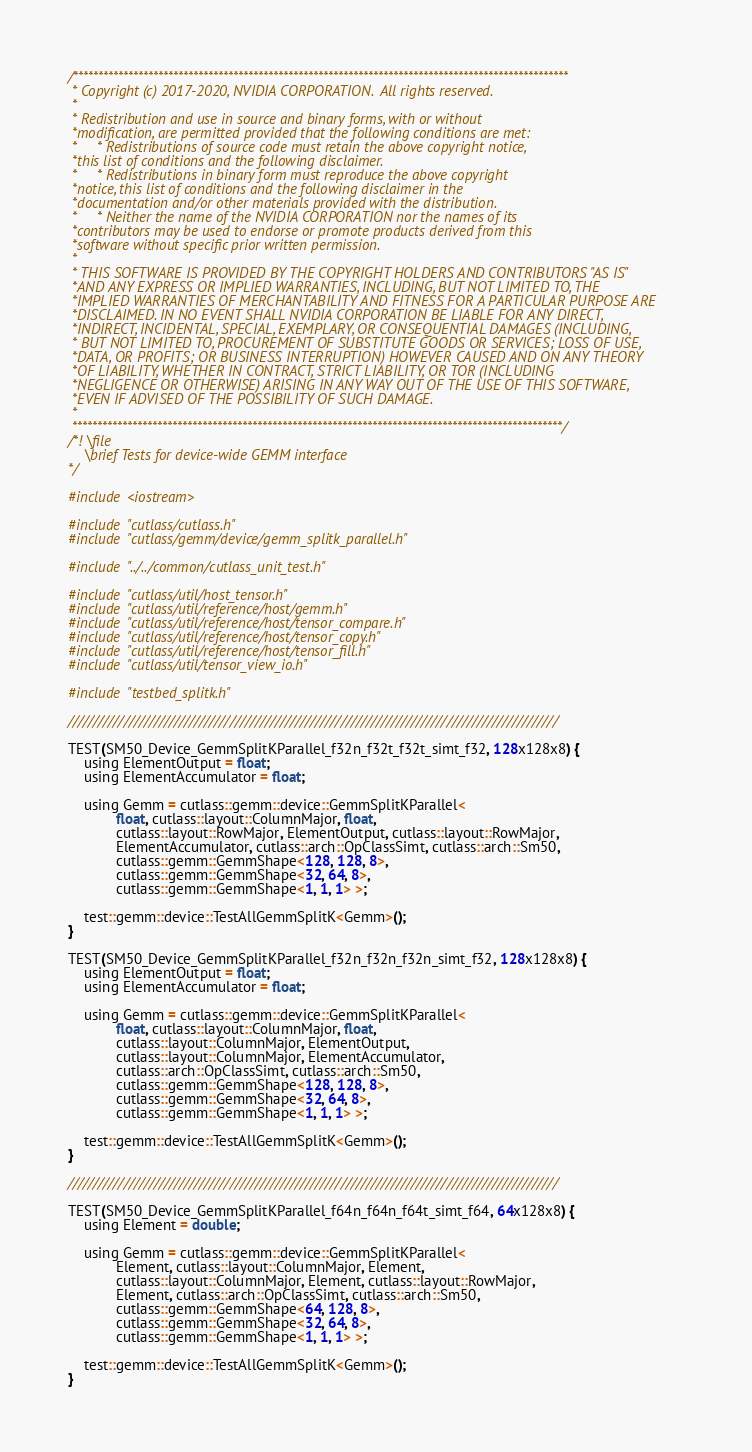Convert code to text. <code><loc_0><loc_0><loc_500><loc_500><_Cuda_>/***************************************************************************************************
 * Copyright (c) 2017-2020, NVIDIA CORPORATION.  All rights reserved.
 *
 * Redistribution and use in source and binary forms, with or without
 *modification, are permitted provided that the following conditions are met:
 *     * Redistributions of source code must retain the above copyright notice,
 *this list of conditions and the following disclaimer.
 *     * Redistributions in binary form must reproduce the above copyright
 *notice, this list of conditions and the following disclaimer in the
 *documentation and/or other materials provided with the distribution.
 *     * Neither the name of the NVIDIA CORPORATION nor the names of its
 *contributors may be used to endorse or promote products derived from this
 *software without specific prior written permission.
 *
 * THIS SOFTWARE IS PROVIDED BY THE COPYRIGHT HOLDERS AND CONTRIBUTORS "AS IS"
 *AND ANY EXPRESS OR IMPLIED WARRANTIES, INCLUDING, BUT NOT LIMITED TO, THE
 *IMPLIED WARRANTIES OF MERCHANTABILITY AND FITNESS FOR A PARTICULAR PURPOSE ARE
 *DISCLAIMED. IN NO EVENT SHALL NVIDIA CORPORATION BE LIABLE FOR ANY DIRECT,
 *INDIRECT, INCIDENTAL, SPECIAL, EXEMPLARY, OR CONSEQUENTIAL DAMAGES (INCLUDING,
 * BUT NOT LIMITED TO, PROCUREMENT OF SUBSTITUTE GOODS OR SERVICES; LOSS OF USE,
 *DATA, OR PROFITS; OR BUSINESS INTERRUPTION) HOWEVER CAUSED AND ON ANY THEORY
 *OF LIABILITY, WHETHER IN CONTRACT, STRICT LIABILITY, OR TOR (INCLUDING
 *NEGLIGENCE OR OTHERWISE) ARISING IN ANY WAY OUT OF THE USE OF THIS SOFTWARE,
 *EVEN IF ADVISED OF THE POSSIBILITY OF SUCH DAMAGE.
 *
 **************************************************************************************************/
/*! \file
    \brief Tests for device-wide GEMM interface
*/

#include <iostream>

#include "cutlass/cutlass.h"
#include "cutlass/gemm/device/gemm_splitk_parallel.h"

#include "../../common/cutlass_unit_test.h"

#include "cutlass/util/host_tensor.h"
#include "cutlass/util/reference/host/gemm.h"
#include "cutlass/util/reference/host/tensor_compare.h"
#include "cutlass/util/reference/host/tensor_copy.h"
#include "cutlass/util/reference/host/tensor_fill.h"
#include "cutlass/util/tensor_view_io.h"

#include "testbed_splitk.h"

/////////////////////////////////////////////////////////////////////////////////////////////////

TEST(SM50_Device_GemmSplitKParallel_f32n_f32t_f32t_simt_f32, 128x128x8) {
    using ElementOutput = float;
    using ElementAccumulator = float;

    using Gemm = cutlass::gemm::device::GemmSplitKParallel<
            float, cutlass::layout::ColumnMajor, float,
            cutlass::layout::RowMajor, ElementOutput, cutlass::layout::RowMajor,
            ElementAccumulator, cutlass::arch::OpClassSimt, cutlass::arch::Sm50,
            cutlass::gemm::GemmShape<128, 128, 8>,
            cutlass::gemm::GemmShape<32, 64, 8>,
            cutlass::gemm::GemmShape<1, 1, 1> >;

    test::gemm::device::TestAllGemmSplitK<Gemm>();
}

TEST(SM50_Device_GemmSplitKParallel_f32n_f32n_f32n_simt_f32, 128x128x8) {
    using ElementOutput = float;
    using ElementAccumulator = float;

    using Gemm = cutlass::gemm::device::GemmSplitKParallel<
            float, cutlass::layout::ColumnMajor, float,
            cutlass::layout::ColumnMajor, ElementOutput,
            cutlass::layout::ColumnMajor, ElementAccumulator,
            cutlass::arch::OpClassSimt, cutlass::arch::Sm50,
            cutlass::gemm::GemmShape<128, 128, 8>,
            cutlass::gemm::GemmShape<32, 64, 8>,
            cutlass::gemm::GemmShape<1, 1, 1> >;

    test::gemm::device::TestAllGemmSplitK<Gemm>();
}

/////////////////////////////////////////////////////////////////////////////////////////////////

TEST(SM50_Device_GemmSplitKParallel_f64n_f64n_f64t_simt_f64, 64x128x8) {
    using Element = double;

    using Gemm = cutlass::gemm::device::GemmSplitKParallel<
            Element, cutlass::layout::ColumnMajor, Element,
            cutlass::layout::ColumnMajor, Element, cutlass::layout::RowMajor,
            Element, cutlass::arch::OpClassSimt, cutlass::arch::Sm50,
            cutlass::gemm::GemmShape<64, 128, 8>,
            cutlass::gemm::GemmShape<32, 64, 8>,
            cutlass::gemm::GemmShape<1, 1, 1> >;

    test::gemm::device::TestAllGemmSplitK<Gemm>();
}
</code> 